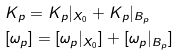<formula> <loc_0><loc_0><loc_500><loc_500>& K _ { p } = K _ { p } | _ { X _ { 0 } } + K _ { p } | _ { B _ { p } } \\ & [ \omega _ { p } ] = [ \omega _ { p } | _ { X _ { 0 } } ] + [ \omega _ { p } | _ { B _ { p } } ]</formula> 